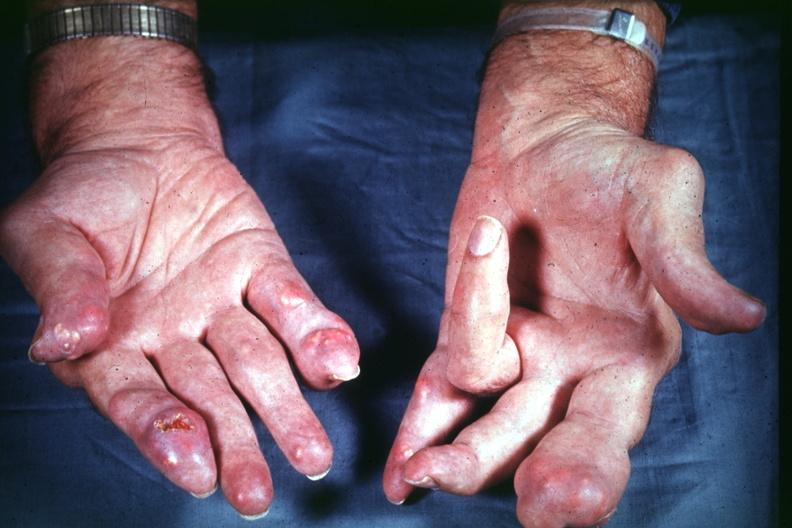re slices of liver and spleen typical tuberculous exudate is present on capsule of liver and spleen present?
Answer the question using a single word or phrase. No 